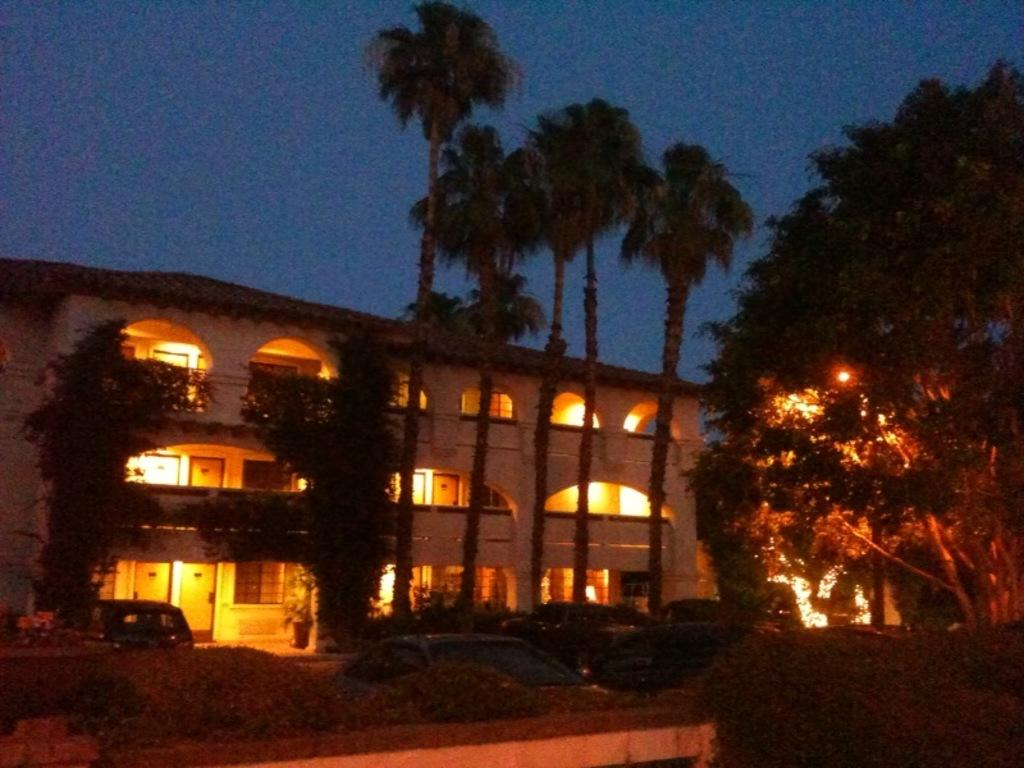What is the lighting condition in the image? The image is taken in the dark. What can be seen parked in the image? There are cars parked in the image. What type of natural elements are visible in the image? There are trees visible in the image. What type of artificial light sources are present in the image? There are lights in the image. What type of man-made structure is visible in the image? There is a building in the image. What is the color of the sky in the background of the image? The sky in the background of the image is dark. How many people are sleeping in the cemetery in the image? There is no cemetery or people sleeping in the image; it features cars, trees, lights, a building, and a dark sky. What type of sock is hanging on the tree in the image? There is no sock present in the image; it only features cars, trees, lights, a building, and a dark sky. 